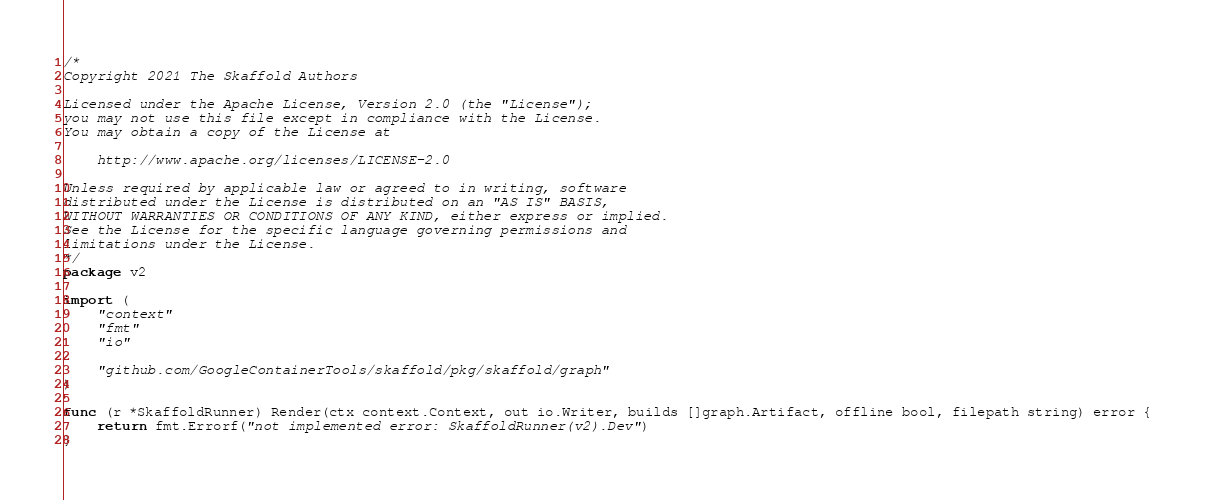Convert code to text. <code><loc_0><loc_0><loc_500><loc_500><_Go_>/*
Copyright 2021 The Skaffold Authors

Licensed under the Apache License, Version 2.0 (the "License");
you may not use this file except in compliance with the License.
You may obtain a copy of the License at

    http://www.apache.org/licenses/LICENSE-2.0

Unless required by applicable law or agreed to in writing, software
distributed under the License is distributed on an "AS IS" BASIS,
WITHOUT WARRANTIES OR CONDITIONS OF ANY KIND, either express or implied.
See the License for the specific language governing permissions and
limitations under the License.
*/
package v2

import (
	"context"
	"fmt"
	"io"

	"github.com/GoogleContainerTools/skaffold/pkg/skaffold/graph"
)

func (r *SkaffoldRunner) Render(ctx context.Context, out io.Writer, builds []graph.Artifact, offline bool, filepath string) error {
	return fmt.Errorf("not implemented error: SkaffoldRunner(v2).Dev")
}
</code> 